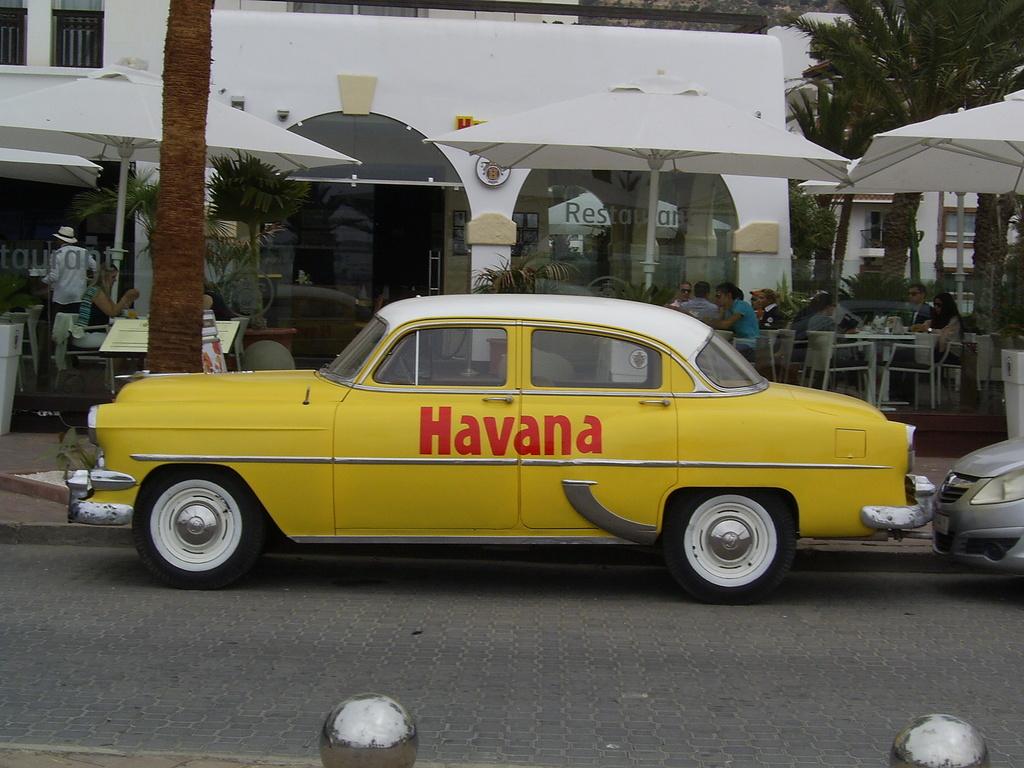What city is this cab in?
Provide a succinct answer. Havana. What city is on the side of the yellow car?
Provide a succinct answer. Havana. 